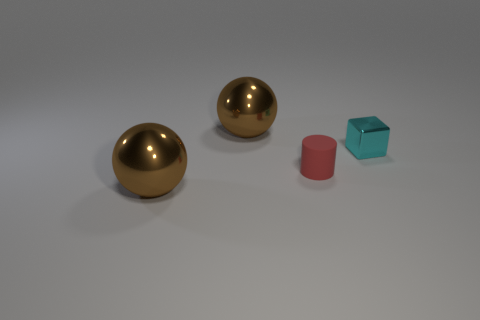Add 4 matte cylinders. How many objects exist? 8 Subtract all cubes. How many objects are left? 3 Subtract all tiny shiny blocks. Subtract all cyan cubes. How many objects are left? 2 Add 4 blocks. How many blocks are left? 5 Add 2 small cyan objects. How many small cyan objects exist? 3 Subtract 0 blue cylinders. How many objects are left? 4 